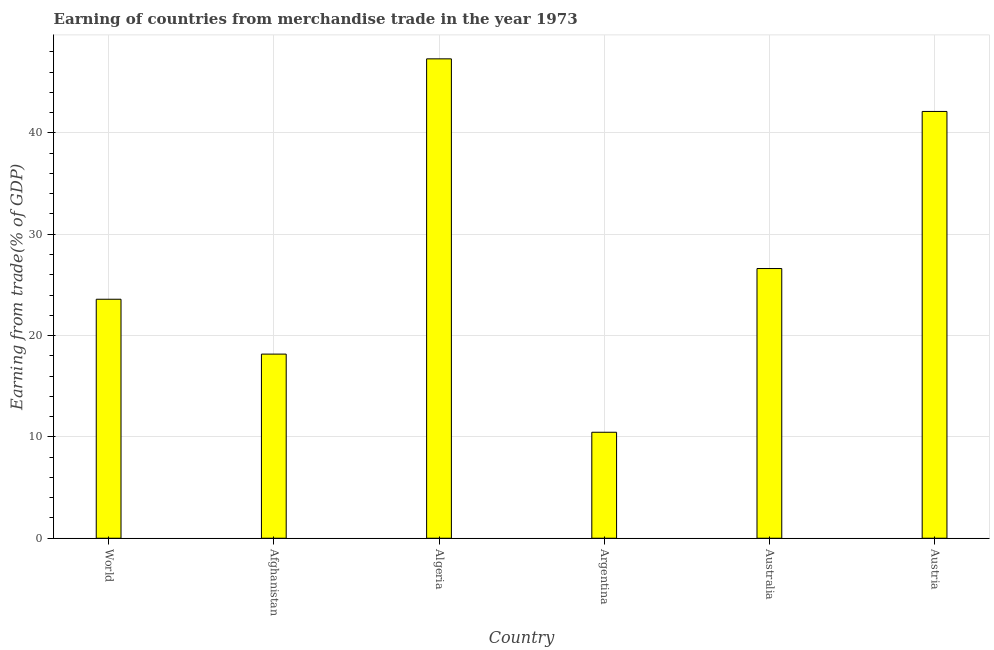Does the graph contain grids?
Ensure brevity in your answer.  Yes. What is the title of the graph?
Provide a succinct answer. Earning of countries from merchandise trade in the year 1973. What is the label or title of the Y-axis?
Offer a terse response. Earning from trade(% of GDP). What is the earning from merchandise trade in Afghanistan?
Offer a terse response. 18.17. Across all countries, what is the maximum earning from merchandise trade?
Your response must be concise. 47.31. Across all countries, what is the minimum earning from merchandise trade?
Keep it short and to the point. 10.46. In which country was the earning from merchandise trade maximum?
Provide a succinct answer. Algeria. What is the sum of the earning from merchandise trade?
Your answer should be compact. 168.27. What is the difference between the earning from merchandise trade in Algeria and Australia?
Your response must be concise. 20.69. What is the average earning from merchandise trade per country?
Provide a succinct answer. 28.04. What is the median earning from merchandise trade?
Keep it short and to the point. 25.1. What is the ratio of the earning from merchandise trade in Algeria to that in Austria?
Your answer should be very brief. 1.12. Is the earning from merchandise trade in Afghanistan less than that in Austria?
Provide a short and direct response. Yes. Is the difference between the earning from merchandise trade in Afghanistan and Argentina greater than the difference between any two countries?
Your answer should be very brief. No. What is the difference between the highest and the second highest earning from merchandise trade?
Provide a succinct answer. 5.19. What is the difference between the highest and the lowest earning from merchandise trade?
Offer a terse response. 36.85. In how many countries, is the earning from merchandise trade greater than the average earning from merchandise trade taken over all countries?
Provide a succinct answer. 2. How many countries are there in the graph?
Keep it short and to the point. 6. What is the Earning from trade(% of GDP) in World?
Provide a succinct answer. 23.59. What is the Earning from trade(% of GDP) of Afghanistan?
Offer a very short reply. 18.17. What is the Earning from trade(% of GDP) in Algeria?
Give a very brief answer. 47.31. What is the Earning from trade(% of GDP) in Argentina?
Your response must be concise. 10.46. What is the Earning from trade(% of GDP) in Australia?
Your answer should be very brief. 26.62. What is the Earning from trade(% of GDP) of Austria?
Ensure brevity in your answer.  42.12. What is the difference between the Earning from trade(% of GDP) in World and Afghanistan?
Offer a very short reply. 5.41. What is the difference between the Earning from trade(% of GDP) in World and Algeria?
Your response must be concise. -23.72. What is the difference between the Earning from trade(% of GDP) in World and Argentina?
Your response must be concise. 13.13. What is the difference between the Earning from trade(% of GDP) in World and Australia?
Your response must be concise. -3.03. What is the difference between the Earning from trade(% of GDP) in World and Austria?
Give a very brief answer. -18.53. What is the difference between the Earning from trade(% of GDP) in Afghanistan and Algeria?
Your answer should be compact. -29.14. What is the difference between the Earning from trade(% of GDP) in Afghanistan and Argentina?
Provide a short and direct response. 7.71. What is the difference between the Earning from trade(% of GDP) in Afghanistan and Australia?
Offer a terse response. -8.44. What is the difference between the Earning from trade(% of GDP) in Afghanistan and Austria?
Give a very brief answer. -23.95. What is the difference between the Earning from trade(% of GDP) in Algeria and Argentina?
Provide a succinct answer. 36.85. What is the difference between the Earning from trade(% of GDP) in Algeria and Australia?
Offer a very short reply. 20.69. What is the difference between the Earning from trade(% of GDP) in Algeria and Austria?
Your answer should be compact. 5.19. What is the difference between the Earning from trade(% of GDP) in Argentina and Australia?
Keep it short and to the point. -16.16. What is the difference between the Earning from trade(% of GDP) in Argentina and Austria?
Make the answer very short. -31.66. What is the difference between the Earning from trade(% of GDP) in Australia and Austria?
Make the answer very short. -15.5. What is the ratio of the Earning from trade(% of GDP) in World to that in Afghanistan?
Your answer should be compact. 1.3. What is the ratio of the Earning from trade(% of GDP) in World to that in Algeria?
Ensure brevity in your answer.  0.5. What is the ratio of the Earning from trade(% of GDP) in World to that in Argentina?
Give a very brief answer. 2.25. What is the ratio of the Earning from trade(% of GDP) in World to that in Australia?
Ensure brevity in your answer.  0.89. What is the ratio of the Earning from trade(% of GDP) in World to that in Austria?
Give a very brief answer. 0.56. What is the ratio of the Earning from trade(% of GDP) in Afghanistan to that in Algeria?
Make the answer very short. 0.38. What is the ratio of the Earning from trade(% of GDP) in Afghanistan to that in Argentina?
Provide a succinct answer. 1.74. What is the ratio of the Earning from trade(% of GDP) in Afghanistan to that in Australia?
Your response must be concise. 0.68. What is the ratio of the Earning from trade(% of GDP) in Afghanistan to that in Austria?
Your response must be concise. 0.43. What is the ratio of the Earning from trade(% of GDP) in Algeria to that in Argentina?
Your answer should be compact. 4.52. What is the ratio of the Earning from trade(% of GDP) in Algeria to that in Australia?
Offer a terse response. 1.78. What is the ratio of the Earning from trade(% of GDP) in Algeria to that in Austria?
Make the answer very short. 1.12. What is the ratio of the Earning from trade(% of GDP) in Argentina to that in Australia?
Offer a terse response. 0.39. What is the ratio of the Earning from trade(% of GDP) in Argentina to that in Austria?
Ensure brevity in your answer.  0.25. What is the ratio of the Earning from trade(% of GDP) in Australia to that in Austria?
Give a very brief answer. 0.63. 